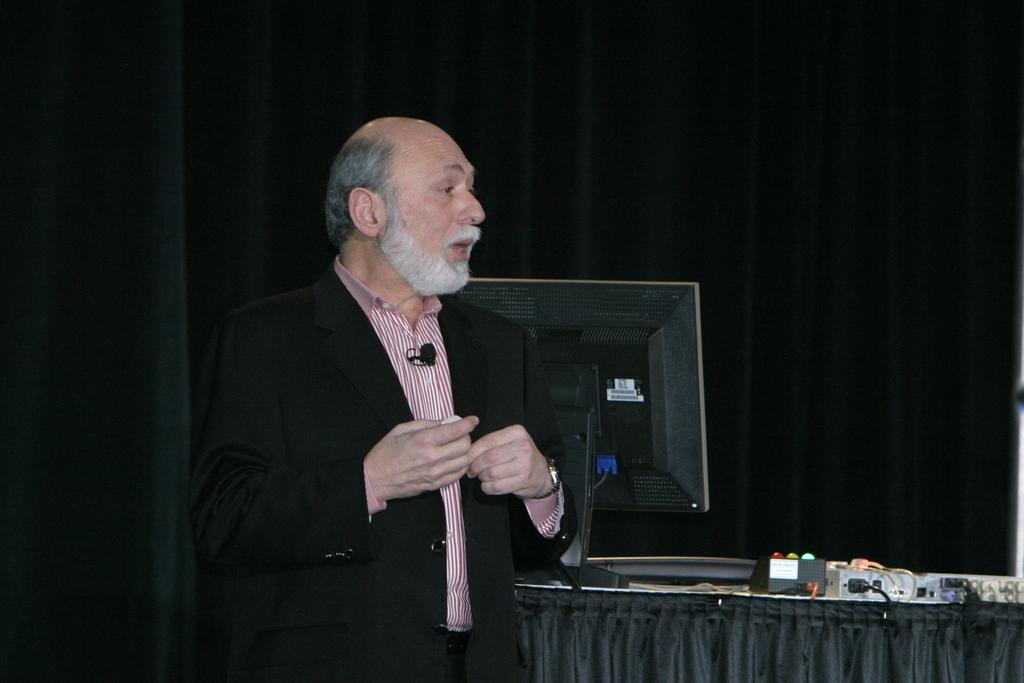Who is present in the image? There is a man in the image. What electronic device can be seen in the image? There is a monitor in the image. What other items are present in the image? There are devices and cloth in the image. Can you describe the background of the image? The background of the image is dark. How many unspecified objects are present in the image? There are some unspecified objects in the image. What type of yam is being served by the man in the image? There is no yam or servant present in the image. How does the man use the devices in the image? The image does not show the man using the devices, so it cannot be determined from the image. 